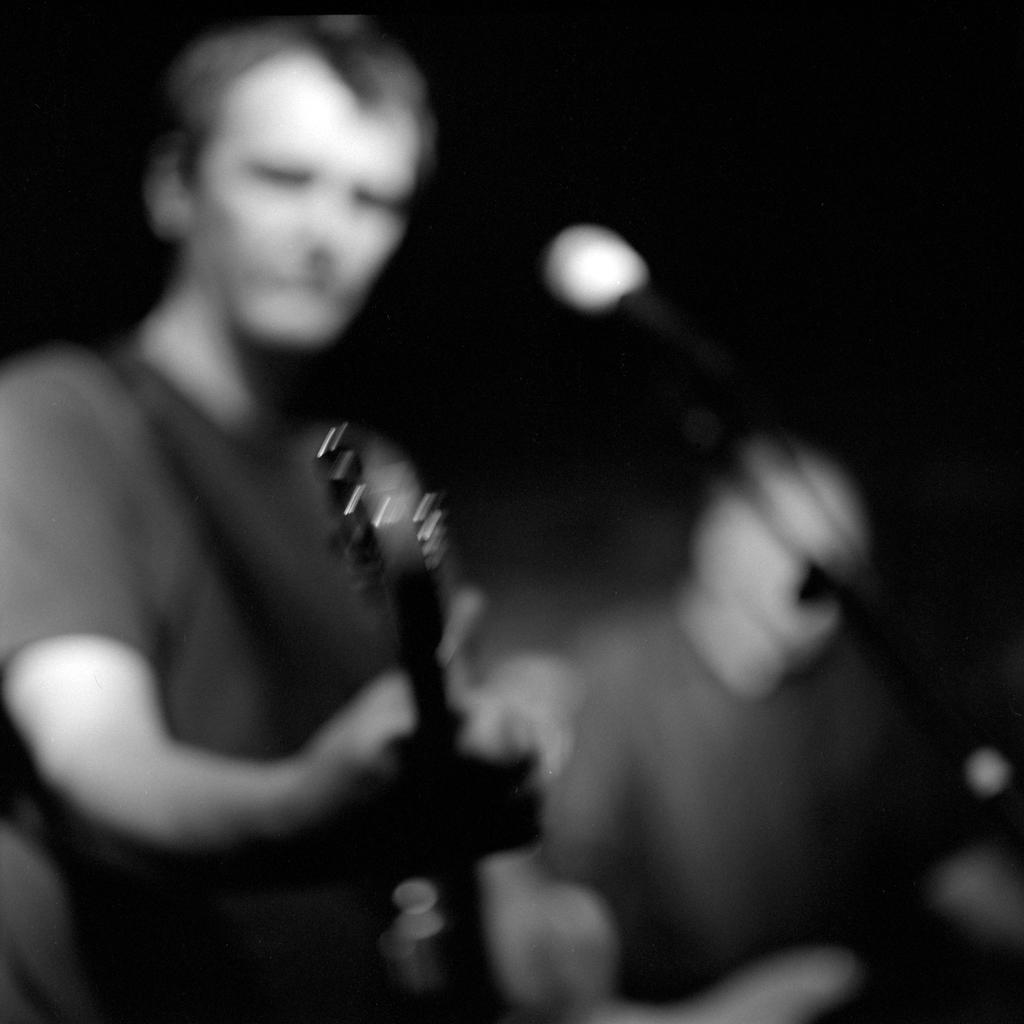What is the color scheme of the image? The image is black and white. How many people are in the image? There are two persons in the image. What is one person doing in the image? One person is playing a guitar. What object is present in the image that is commonly used for amplifying sound? There is a microphone (mike) in the image. What type of farm animals can be seen in the image? There are no farm animals present in the image. What kind of furniture is visible in the image? There is no furniture visible in the image. 